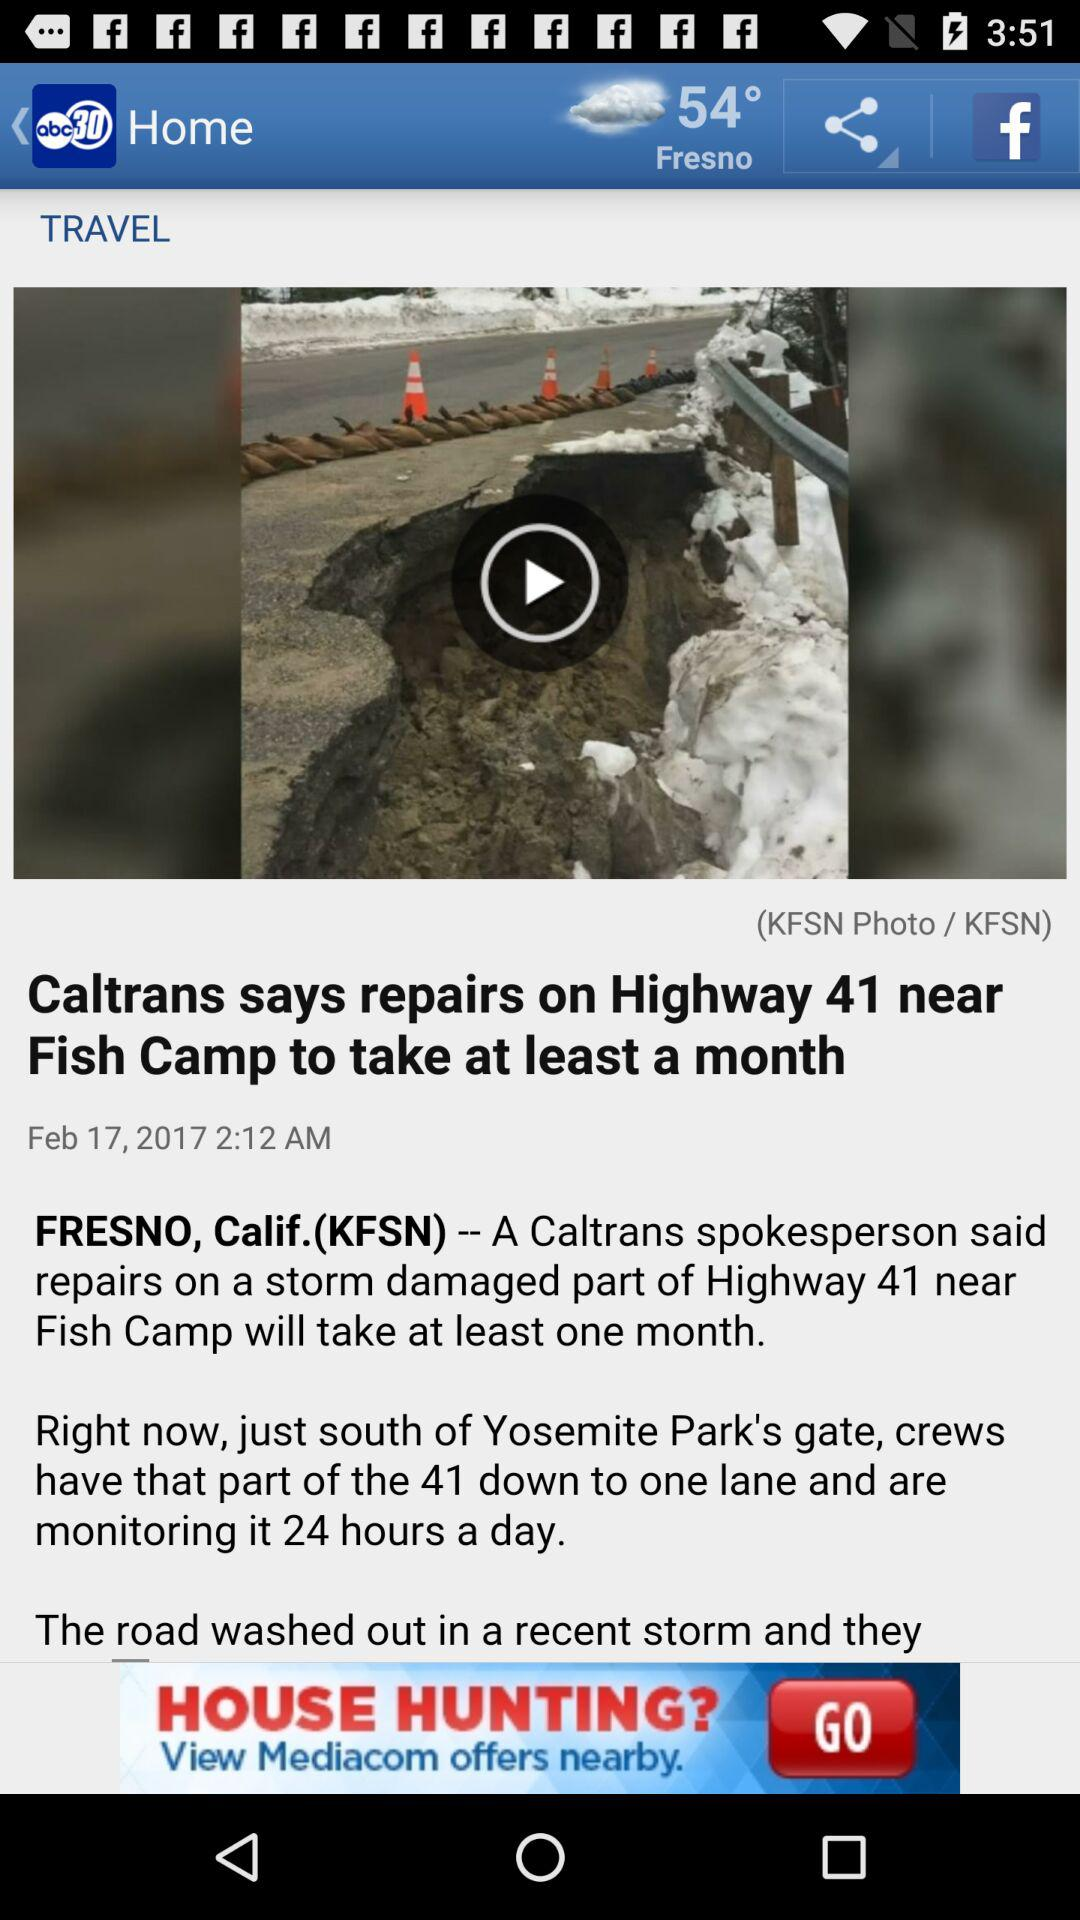How many hours a day are the crews monitoring the road?
Answer the question using a single word or phrase. 24 